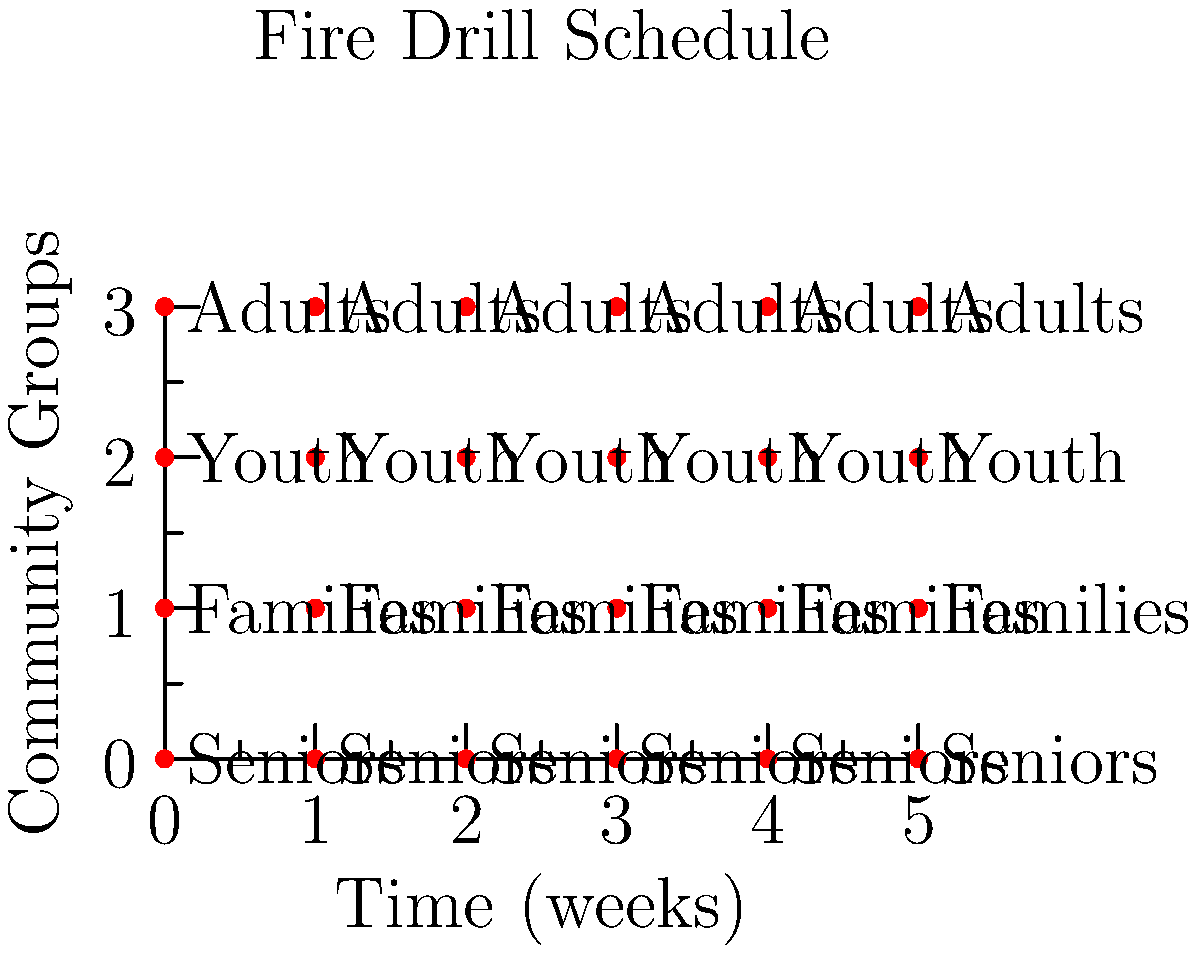A fire safety education program involves conducting fire drills for different community groups on a rotating schedule. The schedule follows a cyclic pattern where each group participates in a drill every 4 weeks. Given that the order of groups is Seniors, Families, Youth, and Adults, what is the order of the groups after 14 weeks, and which mathematical property of cyclic groups does this demonstrate? To solve this problem, we need to follow these steps:

1. Identify the cyclic group structure:
   - The group has 4 elements (Seniors, Families, Youth, Adults)
   - The group operation is rotation of the schedule
   - The identity element is a complete cycle (4 weeks)

2. Calculate the number of complete cycles in 14 weeks:
   $14 \div 4 = 3$ remainder $2$

3. Determine the effect of 3 complete cycles:
   - 3 complete cycles bring us back to the original order
   - This demonstrates the closure property of cyclic groups

4. Account for the remaining 2 weeks:
   - Starting from the original order, rotate twice
   - Seniors → Families → Youth

5. Identify the final order after 14 weeks:
   Youth, Adults, Seniors, Families

6. Recognize the mathematical property:
   This demonstrates the periodic nature of cyclic groups, where the group returns to its initial state after a certain number of operations (in this case, after every 4 rotations).
Answer: Youth, Adults, Seniors, Families; Periodicity 